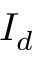Convert formula to latex. <formula><loc_0><loc_0><loc_500><loc_500>I _ { d }</formula> 